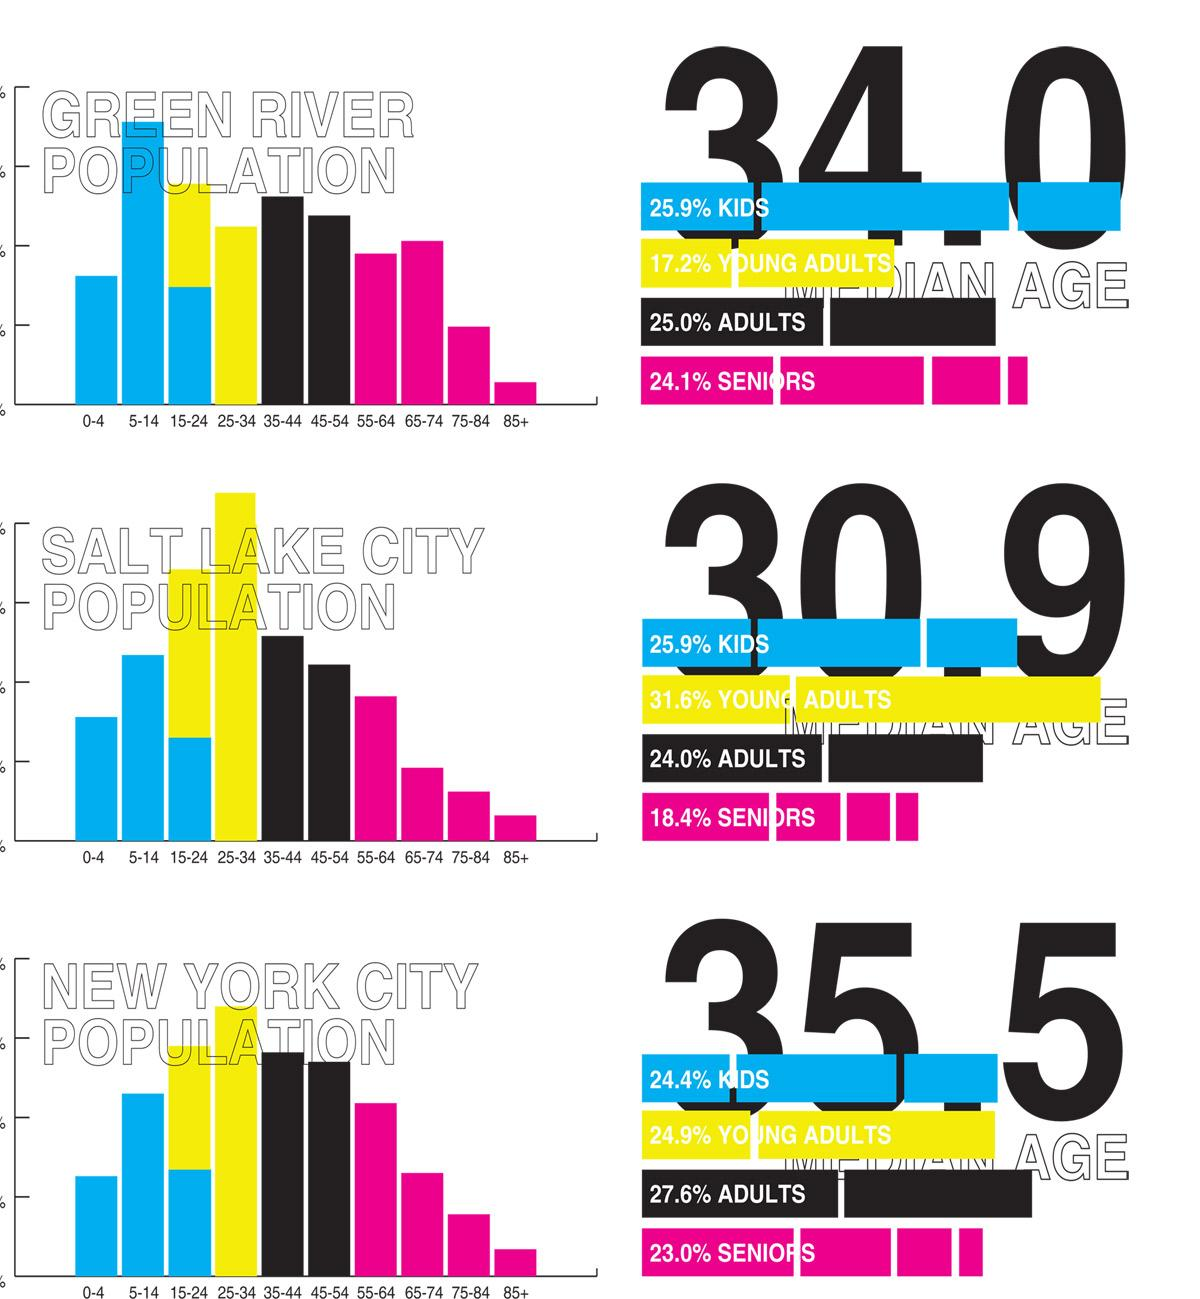Give some essential details in this illustration. According to data, approximately 49.3% of the population in New York City is below the age of 35. The population of New York City between the ages of 35 and 54 is approximately 27.6%. According to the latest data, approximately 49.1% of the population in Green River is aged 35 or above. According to data from Green River, approximately 68.1% of the population is under the age of 55. According to data, 76.9% of the population in New York City is under the age of 55. 